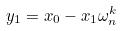<formula> <loc_0><loc_0><loc_500><loc_500>y _ { 1 } = x _ { 0 } - x _ { 1 } \omega _ { n } ^ { k }</formula> 